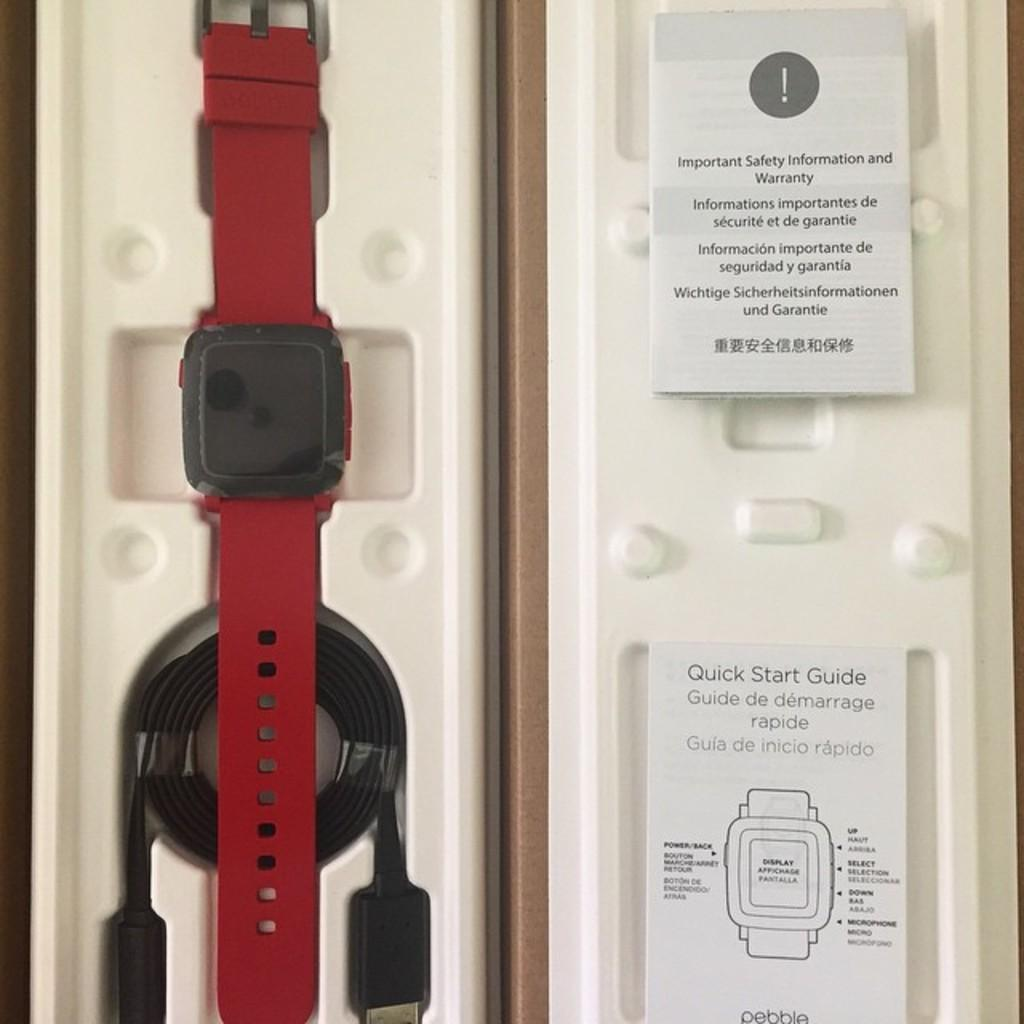<image>
Present a compact description of the photo's key features. A quick start guide is in the case for a smartwatch. 